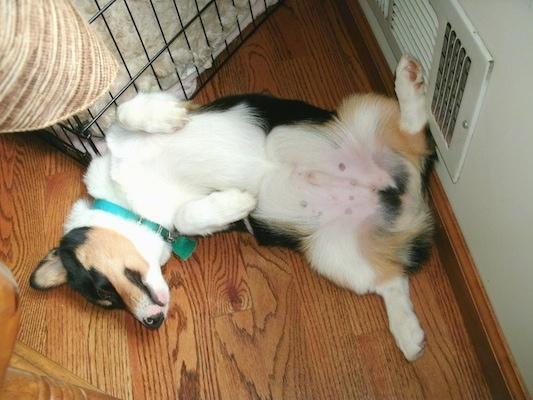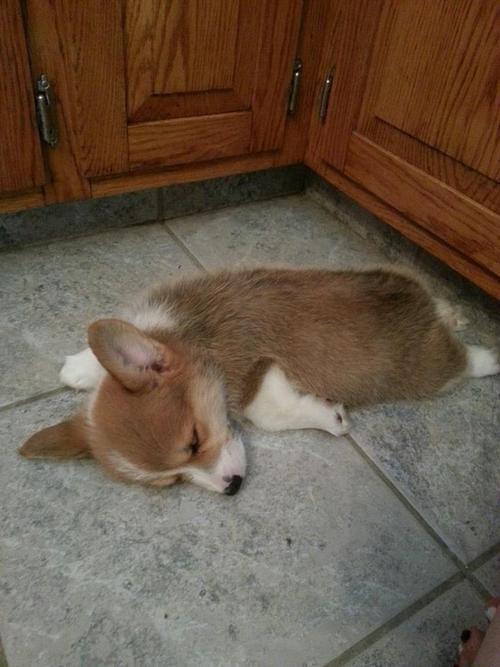The first image is the image on the left, the second image is the image on the right. For the images shown, is this caption "Both dogs are sleeping on their backs." true? Answer yes or no. No. The first image is the image on the left, the second image is the image on the right. Analyze the images presented: Is the assertion "Each image shows one orange-and-white corgi dog, each image shows a dog lying on its back, and one dog is wearing a bluish collar." valid? Answer yes or no. No. 